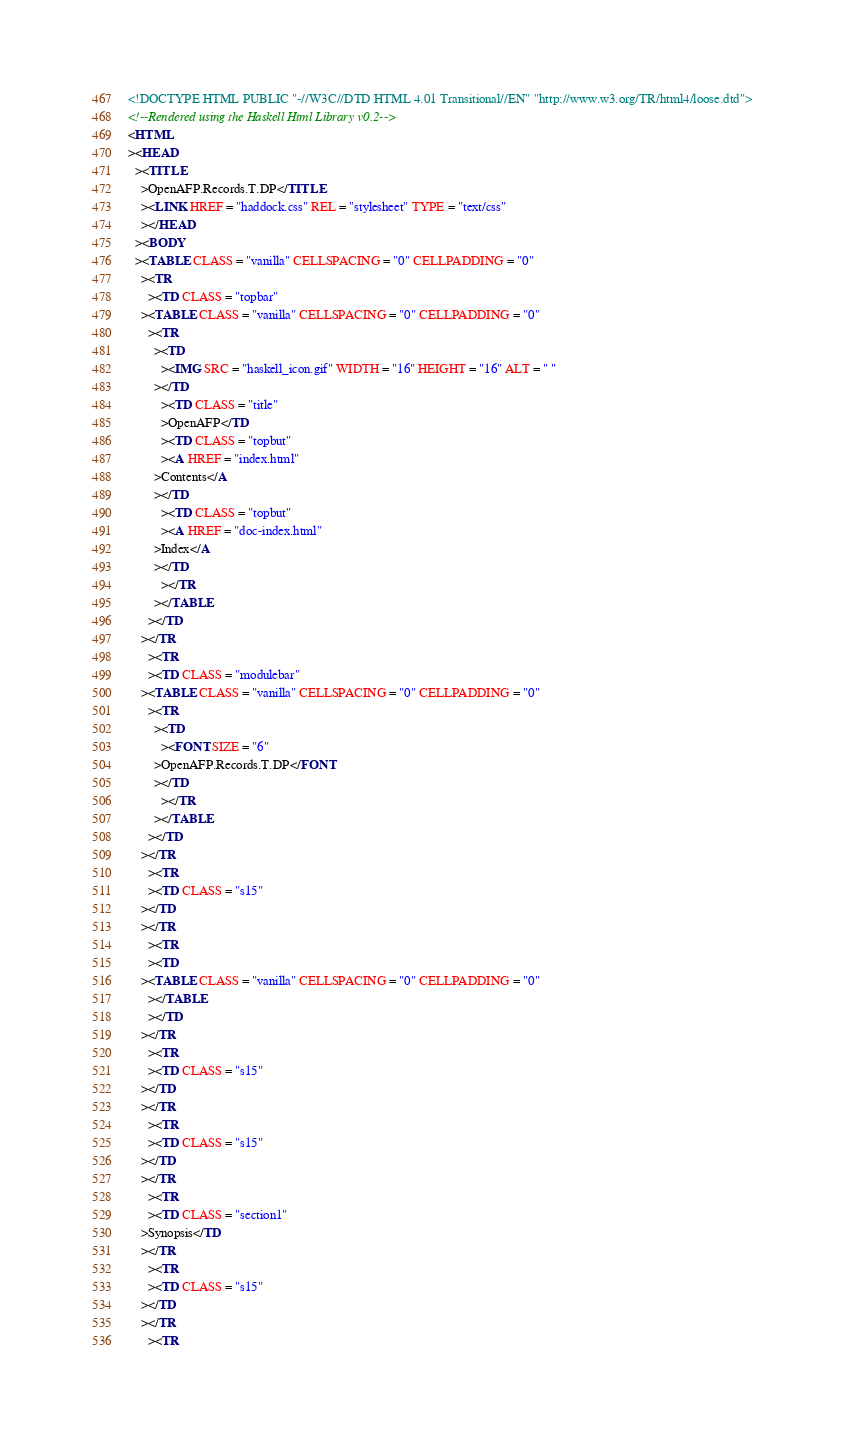Convert code to text. <code><loc_0><loc_0><loc_500><loc_500><_HTML_><!DOCTYPE HTML PUBLIC "-//W3C//DTD HTML 4.01 Transitional//EN" "http://www.w3.org/TR/html4/loose.dtd">
<!--Rendered using the Haskell Html Library v0.2-->
<HTML
><HEAD
  ><TITLE
    >OpenAFP.Records.T.DP</TITLE
    ><LINK HREF = "haddock.css" REL = "stylesheet" TYPE = "text/css"
    ></HEAD
  ><BODY
  ><TABLE CLASS = "vanilla" CELLSPACING = "0" CELLPADDING = "0"
    ><TR
      ><TD CLASS = "topbar"
	><TABLE CLASS = "vanilla" CELLSPACING = "0" CELLPADDING = "0"
	  ><TR
	    ><TD
	      ><IMG SRC = "haskell_icon.gif" WIDTH = "16" HEIGHT = "16" ALT = " "
		></TD
	      ><TD CLASS = "title"
	      >OpenAFP</TD
	      ><TD CLASS = "topbut"
	      ><A HREF = "index.html"
		>Contents</A
		></TD
	      ><TD CLASS = "topbut"
	      ><A HREF = "doc-index.html"
		>Index</A
		></TD
	      ></TR
	    ></TABLE
	  ></TD
	></TR
      ><TR
      ><TD CLASS = "modulebar"
	><TABLE CLASS = "vanilla" CELLSPACING = "0" CELLPADDING = "0"
	  ><TR
	    ><TD
	      ><FONT SIZE = "6"
		>OpenAFP.Records.T.DP</FONT
		></TD
	      ></TR
	    ></TABLE
	  ></TD
	></TR
      ><TR
      ><TD CLASS = "s15"
	></TD
	></TR
      ><TR
      ><TD
	><TABLE CLASS = "vanilla" CELLSPACING = "0" CELLPADDING = "0"
	  ></TABLE
	  ></TD
	></TR
      ><TR
      ><TD CLASS = "s15"
	></TD
	></TR
      ><TR
      ><TD CLASS = "s15"
	></TD
	></TR
      ><TR
      ><TD CLASS = "section1"
	>Synopsis</TD
	></TR
      ><TR
      ><TD CLASS = "s15"
	></TD
	></TR
      ><TR</code> 